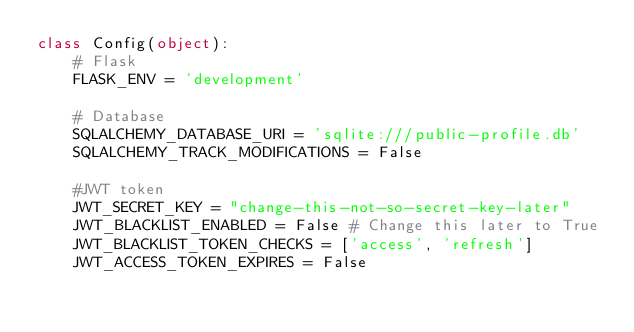<code> <loc_0><loc_0><loc_500><loc_500><_Python_>class Config(object):
    # Flask
    FLASK_ENV = 'development'

    # Database
    SQLALCHEMY_DATABASE_URI = 'sqlite:///public-profile.db'
    SQLALCHEMY_TRACK_MODIFICATIONS = False

    #JWT token
    JWT_SECRET_KEY = "change-this-not-so-secret-key-later"
    JWT_BLACKLIST_ENABLED = False # Change this later to True
    JWT_BLACKLIST_TOKEN_CHECKS = ['access', 'refresh']
    JWT_ACCESS_TOKEN_EXPIRES = False</code> 